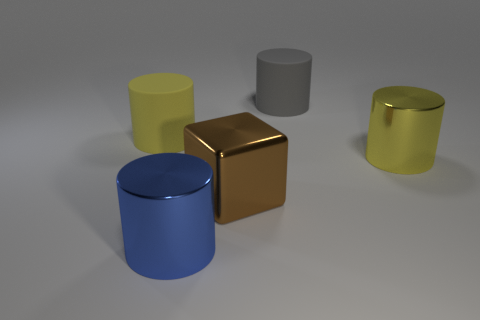Subtract 1 cylinders. How many cylinders are left? 3 Add 5 big metallic cylinders. How many objects exist? 10 Subtract all gray cylinders. Subtract all green spheres. How many cylinders are left? 3 Subtract all cylinders. How many objects are left? 1 Subtract 1 blue cylinders. How many objects are left? 4 Subtract all big gray metallic things. Subtract all cylinders. How many objects are left? 1 Add 5 big yellow rubber cylinders. How many big yellow rubber cylinders are left? 6 Add 5 big cylinders. How many big cylinders exist? 9 